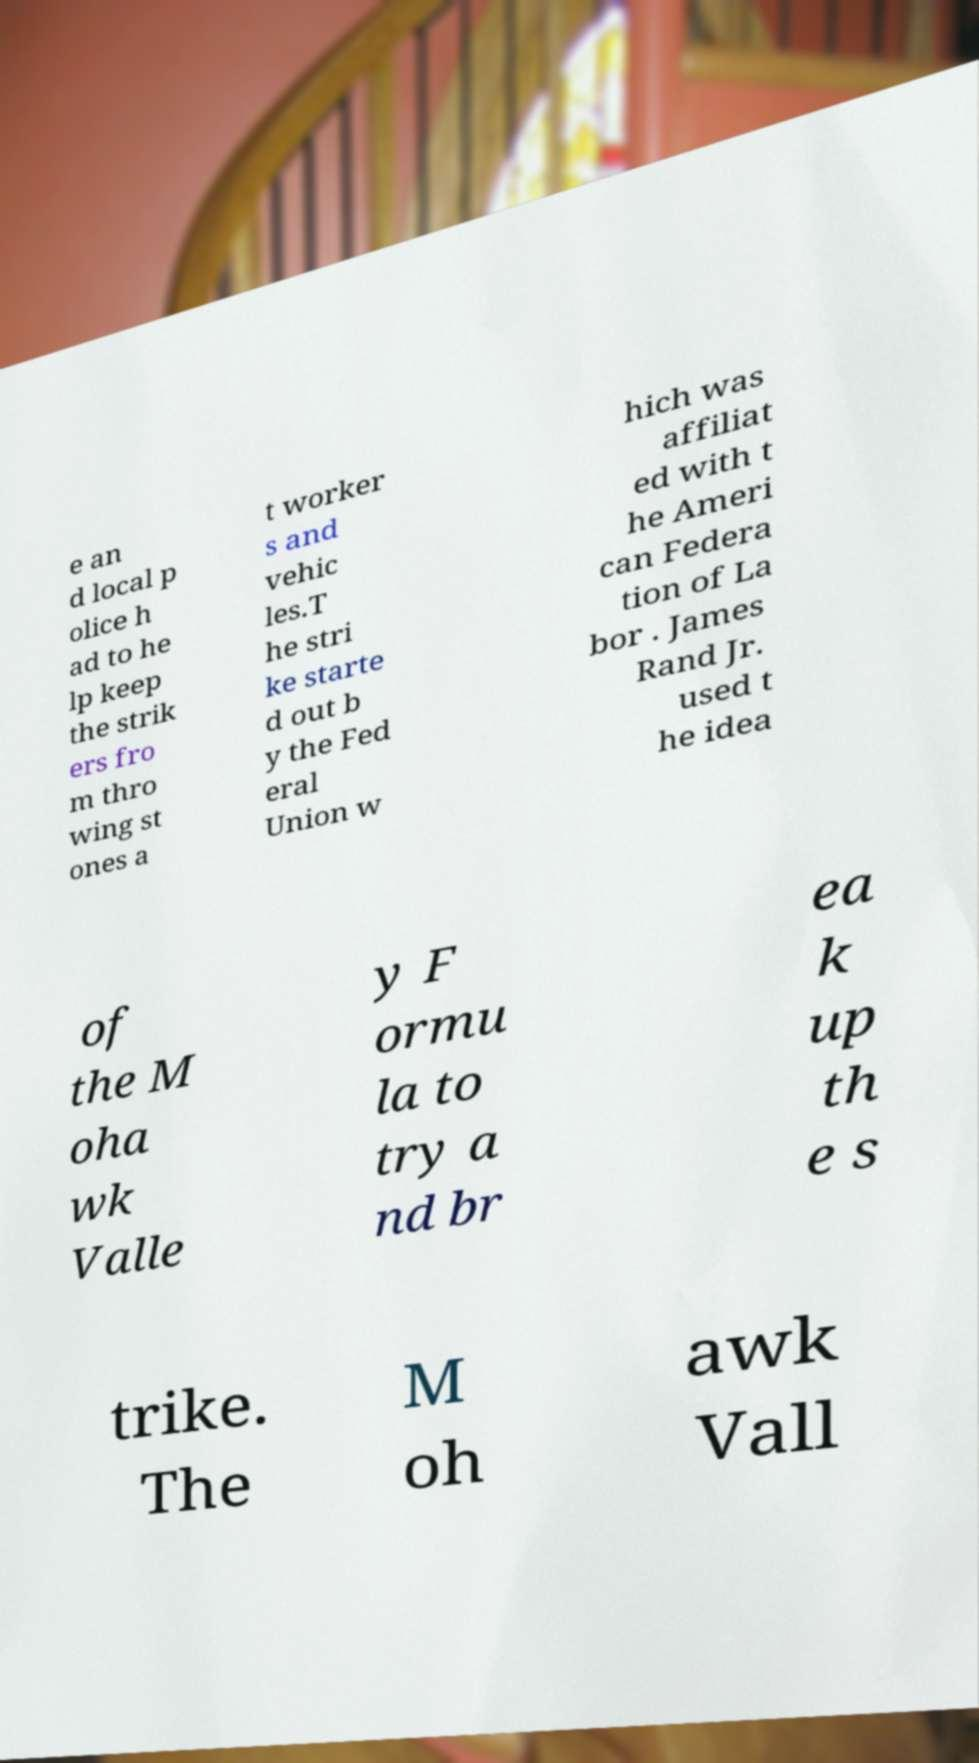Can you read and provide the text displayed in the image?This photo seems to have some interesting text. Can you extract and type it out for me? e an d local p olice h ad to he lp keep the strik ers fro m thro wing st ones a t worker s and vehic les.T he stri ke starte d out b y the Fed eral Union w hich was affiliat ed with t he Ameri can Federa tion of La bor . James Rand Jr. used t he idea of the M oha wk Valle y F ormu la to try a nd br ea k up th e s trike. The M oh awk Vall 